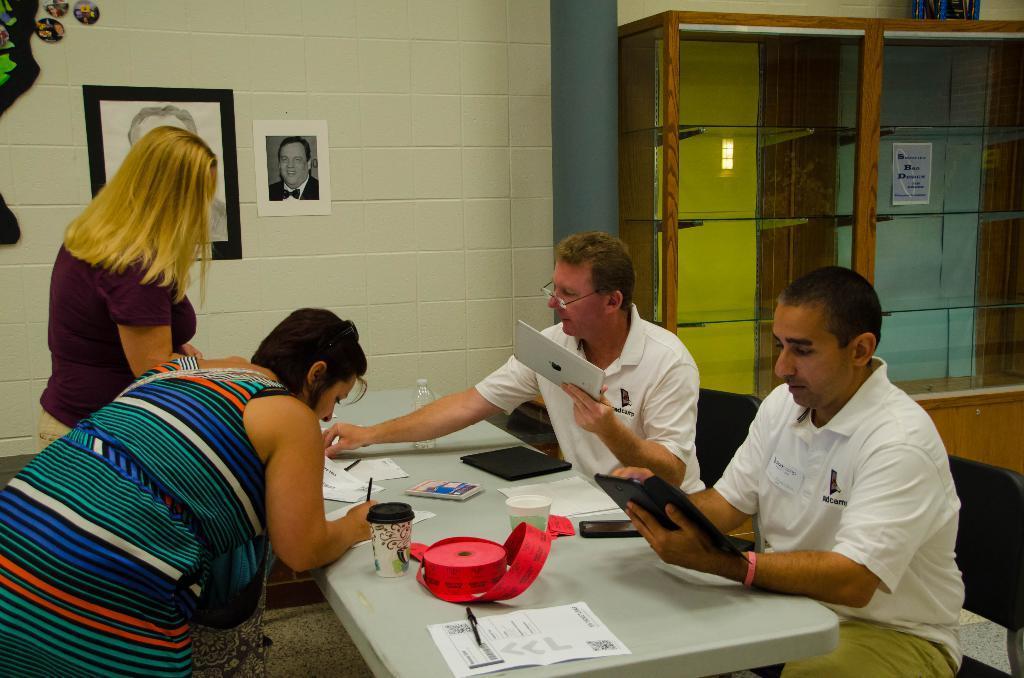Please provide a concise description of this image. This is a picture in a office. In the the center of the picture there is a table, on the table there are paper, cups, books and a water bottle. To the right there are two men in white dress seated. On the left there are two women standing. To the the top left there are two frames. In the center there is a wall. On the right top there is a closet. 